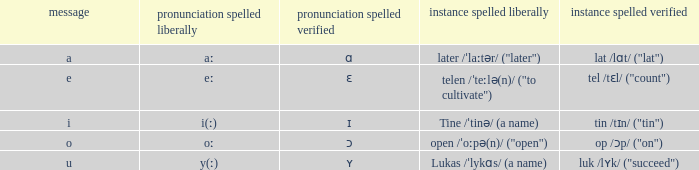What is Pronunciation Spelled Free, when Pronunciation Spelled Checked is "ɑ"? Aː. 